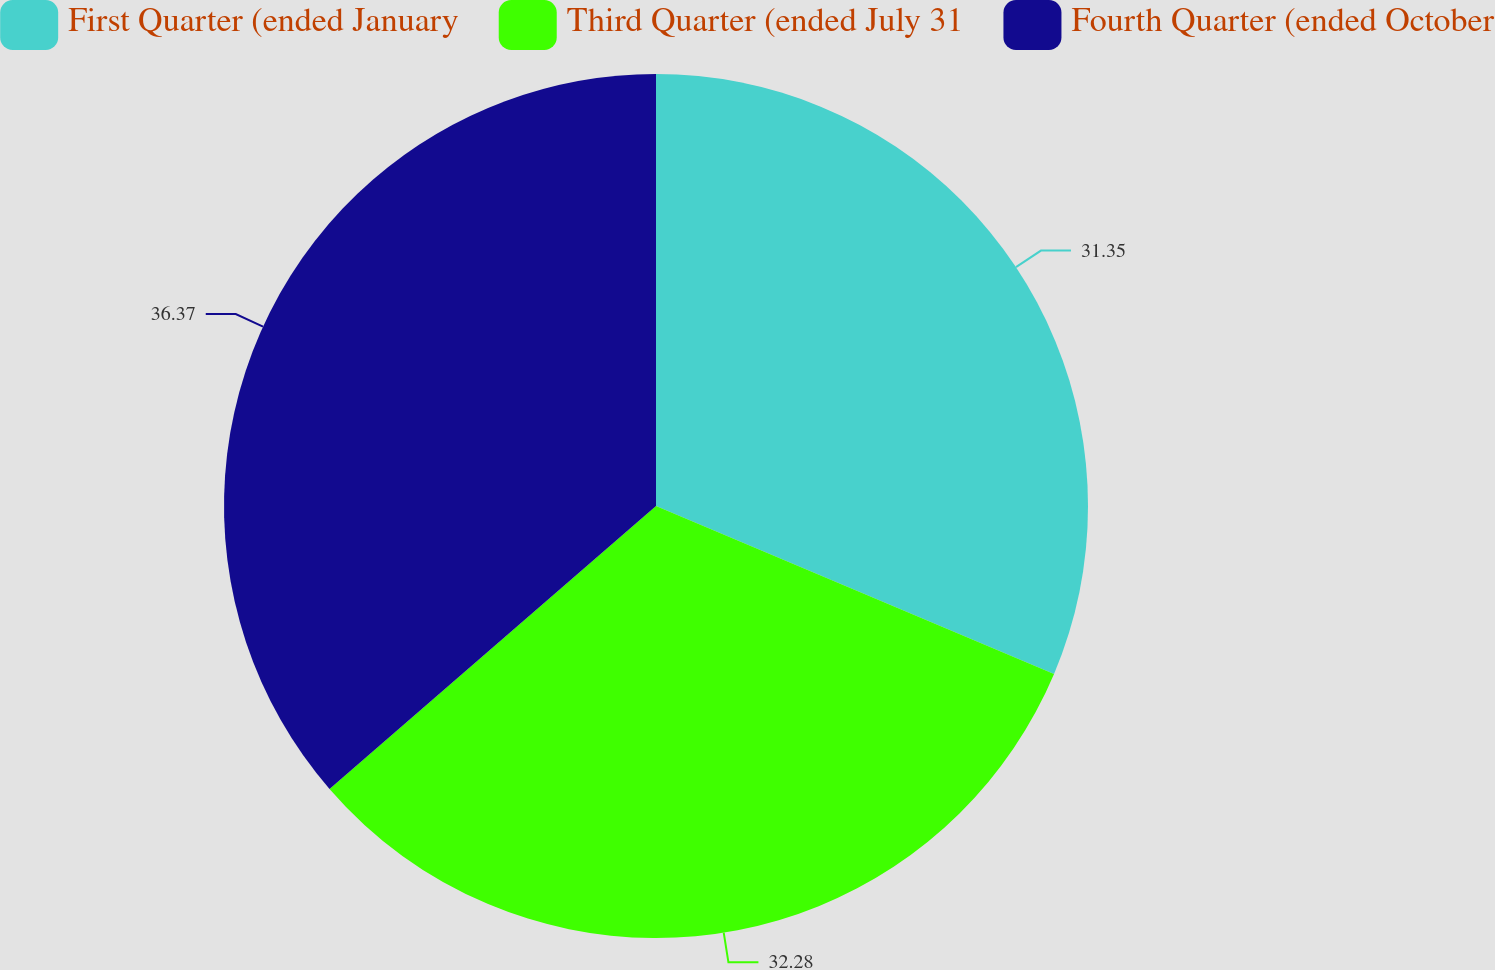<chart> <loc_0><loc_0><loc_500><loc_500><pie_chart><fcel>First Quarter (ended January<fcel>Third Quarter (ended July 31<fcel>Fourth Quarter (ended October<nl><fcel>31.35%<fcel>32.28%<fcel>36.36%<nl></chart> 